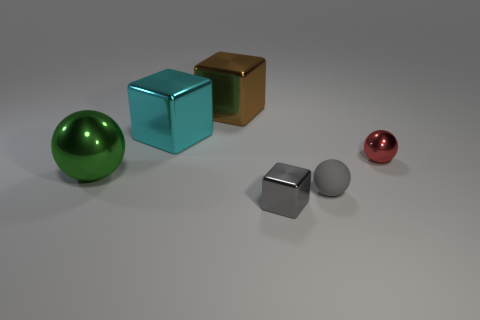Can you describe the lighting in this scene? The lighting in the scene is diffused and soft, suggesting an indoor environment with a single overhead light source that creates gentle shadows directly beneath the objects. 